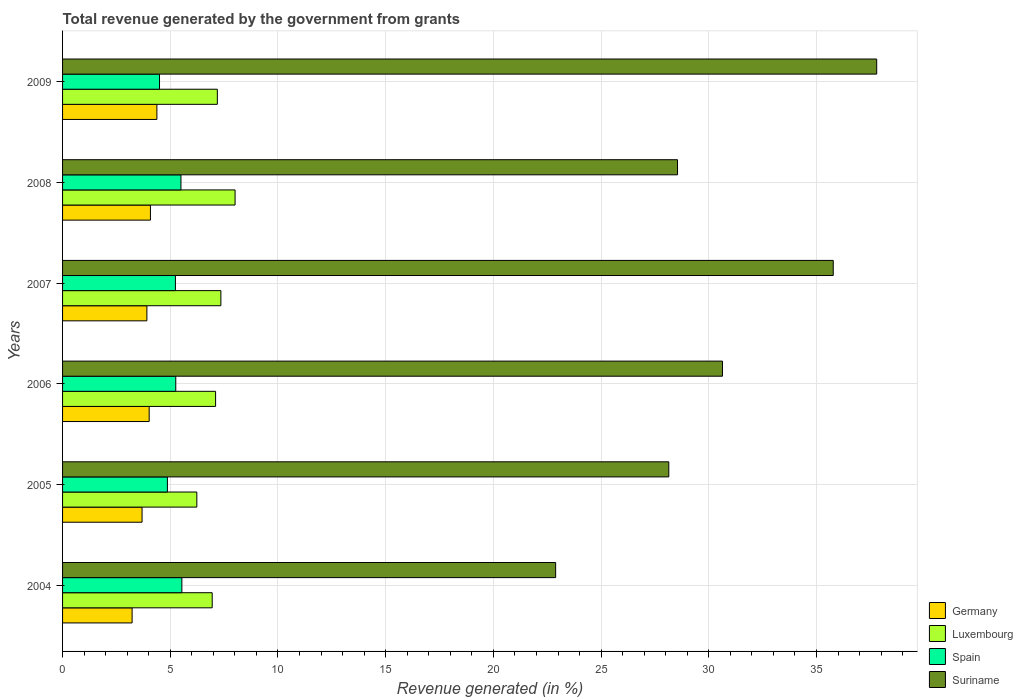How many different coloured bars are there?
Your answer should be very brief. 4. How many groups of bars are there?
Your response must be concise. 6. Are the number of bars per tick equal to the number of legend labels?
Your answer should be compact. Yes. How many bars are there on the 4th tick from the bottom?
Your answer should be very brief. 4. What is the label of the 3rd group of bars from the top?
Your response must be concise. 2007. What is the total revenue generated in Luxembourg in 2006?
Ensure brevity in your answer.  7.1. Across all years, what is the maximum total revenue generated in Suriname?
Offer a terse response. 37.8. Across all years, what is the minimum total revenue generated in Spain?
Your answer should be very brief. 4.5. What is the total total revenue generated in Spain in the graph?
Ensure brevity in your answer.  30.9. What is the difference between the total revenue generated in Suriname in 2005 and that in 2008?
Your answer should be compact. -0.4. What is the difference between the total revenue generated in Spain in 2005 and the total revenue generated in Luxembourg in 2009?
Provide a succinct answer. -2.32. What is the average total revenue generated in Germany per year?
Make the answer very short. 3.89. In the year 2009, what is the difference between the total revenue generated in Germany and total revenue generated in Luxembourg?
Keep it short and to the point. -2.81. In how many years, is the total revenue generated in Spain greater than 12 %?
Your answer should be compact. 0. What is the ratio of the total revenue generated in Suriname in 2005 to that in 2008?
Keep it short and to the point. 0.99. Is the difference between the total revenue generated in Germany in 2008 and 2009 greater than the difference between the total revenue generated in Luxembourg in 2008 and 2009?
Your response must be concise. No. What is the difference between the highest and the second highest total revenue generated in Germany?
Offer a terse response. 0.3. What is the difference between the highest and the lowest total revenue generated in Suriname?
Keep it short and to the point. 14.9. What does the 1st bar from the bottom in 2004 represents?
Provide a short and direct response. Germany. How many bars are there?
Provide a succinct answer. 24. Are all the bars in the graph horizontal?
Make the answer very short. Yes. Does the graph contain any zero values?
Offer a terse response. No. Where does the legend appear in the graph?
Make the answer very short. Bottom right. How many legend labels are there?
Your answer should be compact. 4. How are the legend labels stacked?
Offer a terse response. Vertical. What is the title of the graph?
Make the answer very short. Total revenue generated by the government from grants. Does "Sri Lanka" appear as one of the legend labels in the graph?
Your answer should be very brief. No. What is the label or title of the X-axis?
Give a very brief answer. Revenue generated (in %). What is the Revenue generated (in %) of Germany in 2004?
Offer a very short reply. 3.23. What is the Revenue generated (in %) of Luxembourg in 2004?
Your response must be concise. 6.95. What is the Revenue generated (in %) of Spain in 2004?
Your answer should be compact. 5.54. What is the Revenue generated (in %) in Suriname in 2004?
Your answer should be very brief. 22.89. What is the Revenue generated (in %) of Germany in 2005?
Offer a very short reply. 3.69. What is the Revenue generated (in %) of Luxembourg in 2005?
Give a very brief answer. 6.23. What is the Revenue generated (in %) of Spain in 2005?
Ensure brevity in your answer.  4.87. What is the Revenue generated (in %) in Suriname in 2005?
Ensure brevity in your answer.  28.14. What is the Revenue generated (in %) of Germany in 2006?
Provide a succinct answer. 4.02. What is the Revenue generated (in %) of Luxembourg in 2006?
Your answer should be compact. 7.1. What is the Revenue generated (in %) of Spain in 2006?
Your answer should be compact. 5.26. What is the Revenue generated (in %) of Suriname in 2006?
Your response must be concise. 30.63. What is the Revenue generated (in %) of Germany in 2007?
Make the answer very short. 3.91. What is the Revenue generated (in %) of Luxembourg in 2007?
Offer a very short reply. 7.35. What is the Revenue generated (in %) of Spain in 2007?
Ensure brevity in your answer.  5.24. What is the Revenue generated (in %) in Suriname in 2007?
Provide a succinct answer. 35.78. What is the Revenue generated (in %) in Germany in 2008?
Give a very brief answer. 4.08. What is the Revenue generated (in %) of Luxembourg in 2008?
Make the answer very short. 8.01. What is the Revenue generated (in %) of Spain in 2008?
Ensure brevity in your answer.  5.5. What is the Revenue generated (in %) of Suriname in 2008?
Offer a terse response. 28.55. What is the Revenue generated (in %) in Germany in 2009?
Offer a terse response. 4.38. What is the Revenue generated (in %) in Luxembourg in 2009?
Your response must be concise. 7.19. What is the Revenue generated (in %) of Spain in 2009?
Ensure brevity in your answer.  4.5. What is the Revenue generated (in %) of Suriname in 2009?
Ensure brevity in your answer.  37.8. Across all years, what is the maximum Revenue generated (in %) in Germany?
Offer a very short reply. 4.38. Across all years, what is the maximum Revenue generated (in %) of Luxembourg?
Offer a terse response. 8.01. Across all years, what is the maximum Revenue generated (in %) of Spain?
Your response must be concise. 5.54. Across all years, what is the maximum Revenue generated (in %) in Suriname?
Offer a very short reply. 37.8. Across all years, what is the minimum Revenue generated (in %) of Germany?
Give a very brief answer. 3.23. Across all years, what is the minimum Revenue generated (in %) in Luxembourg?
Keep it short and to the point. 6.23. Across all years, what is the minimum Revenue generated (in %) in Spain?
Ensure brevity in your answer.  4.5. Across all years, what is the minimum Revenue generated (in %) in Suriname?
Keep it short and to the point. 22.89. What is the total Revenue generated (in %) in Germany in the graph?
Provide a short and direct response. 23.31. What is the total Revenue generated (in %) in Luxembourg in the graph?
Keep it short and to the point. 42.83. What is the total Revenue generated (in %) of Spain in the graph?
Your response must be concise. 30.9. What is the total Revenue generated (in %) of Suriname in the graph?
Ensure brevity in your answer.  183.79. What is the difference between the Revenue generated (in %) of Germany in 2004 and that in 2005?
Keep it short and to the point. -0.46. What is the difference between the Revenue generated (in %) in Luxembourg in 2004 and that in 2005?
Offer a very short reply. 0.71. What is the difference between the Revenue generated (in %) of Spain in 2004 and that in 2005?
Your answer should be compact. 0.67. What is the difference between the Revenue generated (in %) in Suriname in 2004 and that in 2005?
Your answer should be very brief. -5.25. What is the difference between the Revenue generated (in %) in Germany in 2004 and that in 2006?
Provide a short and direct response. -0.79. What is the difference between the Revenue generated (in %) in Luxembourg in 2004 and that in 2006?
Ensure brevity in your answer.  -0.16. What is the difference between the Revenue generated (in %) of Spain in 2004 and that in 2006?
Your answer should be very brief. 0.28. What is the difference between the Revenue generated (in %) in Suriname in 2004 and that in 2006?
Give a very brief answer. -7.74. What is the difference between the Revenue generated (in %) in Germany in 2004 and that in 2007?
Your response must be concise. -0.69. What is the difference between the Revenue generated (in %) of Luxembourg in 2004 and that in 2007?
Make the answer very short. -0.4. What is the difference between the Revenue generated (in %) in Spain in 2004 and that in 2007?
Offer a terse response. 0.3. What is the difference between the Revenue generated (in %) of Suriname in 2004 and that in 2007?
Ensure brevity in your answer.  -12.89. What is the difference between the Revenue generated (in %) of Germany in 2004 and that in 2008?
Provide a succinct answer. -0.85. What is the difference between the Revenue generated (in %) of Luxembourg in 2004 and that in 2008?
Ensure brevity in your answer.  -1.06. What is the difference between the Revenue generated (in %) in Spain in 2004 and that in 2008?
Give a very brief answer. 0.04. What is the difference between the Revenue generated (in %) of Suriname in 2004 and that in 2008?
Provide a succinct answer. -5.66. What is the difference between the Revenue generated (in %) of Germany in 2004 and that in 2009?
Offer a terse response. -1.15. What is the difference between the Revenue generated (in %) in Luxembourg in 2004 and that in 2009?
Your answer should be compact. -0.24. What is the difference between the Revenue generated (in %) of Spain in 2004 and that in 2009?
Offer a terse response. 1.04. What is the difference between the Revenue generated (in %) in Suriname in 2004 and that in 2009?
Your response must be concise. -14.9. What is the difference between the Revenue generated (in %) of Germany in 2005 and that in 2006?
Ensure brevity in your answer.  -0.33. What is the difference between the Revenue generated (in %) in Luxembourg in 2005 and that in 2006?
Keep it short and to the point. -0.87. What is the difference between the Revenue generated (in %) in Spain in 2005 and that in 2006?
Provide a short and direct response. -0.39. What is the difference between the Revenue generated (in %) of Suriname in 2005 and that in 2006?
Your answer should be compact. -2.49. What is the difference between the Revenue generated (in %) of Germany in 2005 and that in 2007?
Provide a short and direct response. -0.22. What is the difference between the Revenue generated (in %) of Luxembourg in 2005 and that in 2007?
Your answer should be very brief. -1.12. What is the difference between the Revenue generated (in %) in Spain in 2005 and that in 2007?
Make the answer very short. -0.37. What is the difference between the Revenue generated (in %) in Suriname in 2005 and that in 2007?
Your answer should be compact. -7.63. What is the difference between the Revenue generated (in %) of Germany in 2005 and that in 2008?
Your answer should be very brief. -0.39. What is the difference between the Revenue generated (in %) of Luxembourg in 2005 and that in 2008?
Give a very brief answer. -1.78. What is the difference between the Revenue generated (in %) of Spain in 2005 and that in 2008?
Provide a succinct answer. -0.63. What is the difference between the Revenue generated (in %) in Suriname in 2005 and that in 2008?
Give a very brief answer. -0.4. What is the difference between the Revenue generated (in %) in Germany in 2005 and that in 2009?
Provide a succinct answer. -0.69. What is the difference between the Revenue generated (in %) in Luxembourg in 2005 and that in 2009?
Your response must be concise. -0.95. What is the difference between the Revenue generated (in %) in Spain in 2005 and that in 2009?
Your answer should be compact. 0.37. What is the difference between the Revenue generated (in %) in Suriname in 2005 and that in 2009?
Offer a very short reply. -9.65. What is the difference between the Revenue generated (in %) of Germany in 2006 and that in 2007?
Keep it short and to the point. 0.11. What is the difference between the Revenue generated (in %) in Luxembourg in 2006 and that in 2007?
Ensure brevity in your answer.  -0.25. What is the difference between the Revenue generated (in %) of Spain in 2006 and that in 2007?
Provide a short and direct response. 0.02. What is the difference between the Revenue generated (in %) in Suriname in 2006 and that in 2007?
Give a very brief answer. -5.14. What is the difference between the Revenue generated (in %) of Germany in 2006 and that in 2008?
Offer a terse response. -0.06. What is the difference between the Revenue generated (in %) in Luxembourg in 2006 and that in 2008?
Provide a short and direct response. -0.9. What is the difference between the Revenue generated (in %) of Spain in 2006 and that in 2008?
Give a very brief answer. -0.24. What is the difference between the Revenue generated (in %) of Suriname in 2006 and that in 2008?
Offer a terse response. 2.09. What is the difference between the Revenue generated (in %) of Germany in 2006 and that in 2009?
Ensure brevity in your answer.  -0.36. What is the difference between the Revenue generated (in %) in Luxembourg in 2006 and that in 2009?
Make the answer very short. -0.08. What is the difference between the Revenue generated (in %) in Spain in 2006 and that in 2009?
Give a very brief answer. 0.75. What is the difference between the Revenue generated (in %) of Suriname in 2006 and that in 2009?
Your response must be concise. -7.16. What is the difference between the Revenue generated (in %) in Germany in 2007 and that in 2008?
Your answer should be compact. -0.16. What is the difference between the Revenue generated (in %) in Luxembourg in 2007 and that in 2008?
Offer a very short reply. -0.66. What is the difference between the Revenue generated (in %) of Spain in 2007 and that in 2008?
Your response must be concise. -0.26. What is the difference between the Revenue generated (in %) of Suriname in 2007 and that in 2008?
Ensure brevity in your answer.  7.23. What is the difference between the Revenue generated (in %) in Germany in 2007 and that in 2009?
Ensure brevity in your answer.  -0.46. What is the difference between the Revenue generated (in %) of Luxembourg in 2007 and that in 2009?
Offer a very short reply. 0.16. What is the difference between the Revenue generated (in %) of Spain in 2007 and that in 2009?
Offer a very short reply. 0.74. What is the difference between the Revenue generated (in %) in Suriname in 2007 and that in 2009?
Ensure brevity in your answer.  -2.02. What is the difference between the Revenue generated (in %) of Germany in 2008 and that in 2009?
Your answer should be very brief. -0.3. What is the difference between the Revenue generated (in %) of Luxembourg in 2008 and that in 2009?
Your response must be concise. 0.82. What is the difference between the Revenue generated (in %) of Suriname in 2008 and that in 2009?
Provide a short and direct response. -9.25. What is the difference between the Revenue generated (in %) in Germany in 2004 and the Revenue generated (in %) in Luxembourg in 2005?
Offer a very short reply. -3. What is the difference between the Revenue generated (in %) of Germany in 2004 and the Revenue generated (in %) of Spain in 2005?
Provide a short and direct response. -1.64. What is the difference between the Revenue generated (in %) of Germany in 2004 and the Revenue generated (in %) of Suriname in 2005?
Your answer should be very brief. -24.91. What is the difference between the Revenue generated (in %) in Luxembourg in 2004 and the Revenue generated (in %) in Spain in 2005?
Your answer should be very brief. 2.08. What is the difference between the Revenue generated (in %) in Luxembourg in 2004 and the Revenue generated (in %) in Suriname in 2005?
Provide a succinct answer. -21.2. What is the difference between the Revenue generated (in %) in Spain in 2004 and the Revenue generated (in %) in Suriname in 2005?
Make the answer very short. -22.61. What is the difference between the Revenue generated (in %) of Germany in 2004 and the Revenue generated (in %) of Luxembourg in 2006?
Provide a succinct answer. -3.88. What is the difference between the Revenue generated (in %) of Germany in 2004 and the Revenue generated (in %) of Spain in 2006?
Keep it short and to the point. -2.03. What is the difference between the Revenue generated (in %) in Germany in 2004 and the Revenue generated (in %) in Suriname in 2006?
Your answer should be compact. -27.41. What is the difference between the Revenue generated (in %) of Luxembourg in 2004 and the Revenue generated (in %) of Spain in 2006?
Your answer should be very brief. 1.69. What is the difference between the Revenue generated (in %) in Luxembourg in 2004 and the Revenue generated (in %) in Suriname in 2006?
Keep it short and to the point. -23.69. What is the difference between the Revenue generated (in %) in Spain in 2004 and the Revenue generated (in %) in Suriname in 2006?
Offer a very short reply. -25.1. What is the difference between the Revenue generated (in %) in Germany in 2004 and the Revenue generated (in %) in Luxembourg in 2007?
Offer a terse response. -4.12. What is the difference between the Revenue generated (in %) of Germany in 2004 and the Revenue generated (in %) of Spain in 2007?
Provide a succinct answer. -2.01. What is the difference between the Revenue generated (in %) in Germany in 2004 and the Revenue generated (in %) in Suriname in 2007?
Offer a very short reply. -32.55. What is the difference between the Revenue generated (in %) of Luxembourg in 2004 and the Revenue generated (in %) of Spain in 2007?
Your answer should be compact. 1.71. What is the difference between the Revenue generated (in %) in Luxembourg in 2004 and the Revenue generated (in %) in Suriname in 2007?
Provide a short and direct response. -28.83. What is the difference between the Revenue generated (in %) in Spain in 2004 and the Revenue generated (in %) in Suriname in 2007?
Provide a short and direct response. -30.24. What is the difference between the Revenue generated (in %) in Germany in 2004 and the Revenue generated (in %) in Luxembourg in 2008?
Your answer should be very brief. -4.78. What is the difference between the Revenue generated (in %) in Germany in 2004 and the Revenue generated (in %) in Spain in 2008?
Your answer should be compact. -2.27. What is the difference between the Revenue generated (in %) in Germany in 2004 and the Revenue generated (in %) in Suriname in 2008?
Your answer should be compact. -25.32. What is the difference between the Revenue generated (in %) of Luxembourg in 2004 and the Revenue generated (in %) of Spain in 2008?
Make the answer very short. 1.45. What is the difference between the Revenue generated (in %) in Luxembourg in 2004 and the Revenue generated (in %) in Suriname in 2008?
Ensure brevity in your answer.  -21.6. What is the difference between the Revenue generated (in %) of Spain in 2004 and the Revenue generated (in %) of Suriname in 2008?
Offer a very short reply. -23.01. What is the difference between the Revenue generated (in %) of Germany in 2004 and the Revenue generated (in %) of Luxembourg in 2009?
Your response must be concise. -3.96. What is the difference between the Revenue generated (in %) in Germany in 2004 and the Revenue generated (in %) in Spain in 2009?
Ensure brevity in your answer.  -1.27. What is the difference between the Revenue generated (in %) of Germany in 2004 and the Revenue generated (in %) of Suriname in 2009?
Your answer should be very brief. -34.57. What is the difference between the Revenue generated (in %) in Luxembourg in 2004 and the Revenue generated (in %) in Spain in 2009?
Give a very brief answer. 2.45. What is the difference between the Revenue generated (in %) in Luxembourg in 2004 and the Revenue generated (in %) in Suriname in 2009?
Give a very brief answer. -30.85. What is the difference between the Revenue generated (in %) in Spain in 2004 and the Revenue generated (in %) in Suriname in 2009?
Ensure brevity in your answer.  -32.26. What is the difference between the Revenue generated (in %) of Germany in 2005 and the Revenue generated (in %) of Luxembourg in 2006?
Your response must be concise. -3.41. What is the difference between the Revenue generated (in %) of Germany in 2005 and the Revenue generated (in %) of Spain in 2006?
Offer a very short reply. -1.56. What is the difference between the Revenue generated (in %) in Germany in 2005 and the Revenue generated (in %) in Suriname in 2006?
Make the answer very short. -26.94. What is the difference between the Revenue generated (in %) of Luxembourg in 2005 and the Revenue generated (in %) of Spain in 2006?
Keep it short and to the point. 0.98. What is the difference between the Revenue generated (in %) of Luxembourg in 2005 and the Revenue generated (in %) of Suriname in 2006?
Ensure brevity in your answer.  -24.4. What is the difference between the Revenue generated (in %) in Spain in 2005 and the Revenue generated (in %) in Suriname in 2006?
Your answer should be compact. -25.77. What is the difference between the Revenue generated (in %) in Germany in 2005 and the Revenue generated (in %) in Luxembourg in 2007?
Provide a succinct answer. -3.66. What is the difference between the Revenue generated (in %) in Germany in 2005 and the Revenue generated (in %) in Spain in 2007?
Keep it short and to the point. -1.55. What is the difference between the Revenue generated (in %) in Germany in 2005 and the Revenue generated (in %) in Suriname in 2007?
Make the answer very short. -32.09. What is the difference between the Revenue generated (in %) of Luxembourg in 2005 and the Revenue generated (in %) of Suriname in 2007?
Ensure brevity in your answer.  -29.54. What is the difference between the Revenue generated (in %) in Spain in 2005 and the Revenue generated (in %) in Suriname in 2007?
Ensure brevity in your answer.  -30.91. What is the difference between the Revenue generated (in %) of Germany in 2005 and the Revenue generated (in %) of Luxembourg in 2008?
Offer a very short reply. -4.32. What is the difference between the Revenue generated (in %) in Germany in 2005 and the Revenue generated (in %) in Spain in 2008?
Your answer should be very brief. -1.81. What is the difference between the Revenue generated (in %) in Germany in 2005 and the Revenue generated (in %) in Suriname in 2008?
Make the answer very short. -24.86. What is the difference between the Revenue generated (in %) of Luxembourg in 2005 and the Revenue generated (in %) of Spain in 2008?
Offer a very short reply. 0.74. What is the difference between the Revenue generated (in %) of Luxembourg in 2005 and the Revenue generated (in %) of Suriname in 2008?
Your response must be concise. -22.32. What is the difference between the Revenue generated (in %) in Spain in 2005 and the Revenue generated (in %) in Suriname in 2008?
Ensure brevity in your answer.  -23.68. What is the difference between the Revenue generated (in %) in Germany in 2005 and the Revenue generated (in %) in Luxembourg in 2009?
Your answer should be very brief. -3.49. What is the difference between the Revenue generated (in %) of Germany in 2005 and the Revenue generated (in %) of Spain in 2009?
Provide a succinct answer. -0.81. What is the difference between the Revenue generated (in %) in Germany in 2005 and the Revenue generated (in %) in Suriname in 2009?
Your answer should be compact. -34.1. What is the difference between the Revenue generated (in %) in Luxembourg in 2005 and the Revenue generated (in %) in Spain in 2009?
Your answer should be very brief. 1.73. What is the difference between the Revenue generated (in %) in Luxembourg in 2005 and the Revenue generated (in %) in Suriname in 2009?
Your answer should be very brief. -31.56. What is the difference between the Revenue generated (in %) in Spain in 2005 and the Revenue generated (in %) in Suriname in 2009?
Provide a succinct answer. -32.93. What is the difference between the Revenue generated (in %) of Germany in 2006 and the Revenue generated (in %) of Luxembourg in 2007?
Provide a succinct answer. -3.33. What is the difference between the Revenue generated (in %) in Germany in 2006 and the Revenue generated (in %) in Spain in 2007?
Offer a terse response. -1.22. What is the difference between the Revenue generated (in %) in Germany in 2006 and the Revenue generated (in %) in Suriname in 2007?
Provide a short and direct response. -31.76. What is the difference between the Revenue generated (in %) in Luxembourg in 2006 and the Revenue generated (in %) in Spain in 2007?
Your answer should be compact. 1.86. What is the difference between the Revenue generated (in %) in Luxembourg in 2006 and the Revenue generated (in %) in Suriname in 2007?
Make the answer very short. -28.67. What is the difference between the Revenue generated (in %) in Spain in 2006 and the Revenue generated (in %) in Suriname in 2007?
Provide a short and direct response. -30.52. What is the difference between the Revenue generated (in %) of Germany in 2006 and the Revenue generated (in %) of Luxembourg in 2008?
Provide a short and direct response. -3.99. What is the difference between the Revenue generated (in %) in Germany in 2006 and the Revenue generated (in %) in Spain in 2008?
Make the answer very short. -1.48. What is the difference between the Revenue generated (in %) in Germany in 2006 and the Revenue generated (in %) in Suriname in 2008?
Provide a short and direct response. -24.53. What is the difference between the Revenue generated (in %) of Luxembourg in 2006 and the Revenue generated (in %) of Spain in 2008?
Your answer should be very brief. 1.61. What is the difference between the Revenue generated (in %) of Luxembourg in 2006 and the Revenue generated (in %) of Suriname in 2008?
Offer a terse response. -21.44. What is the difference between the Revenue generated (in %) in Spain in 2006 and the Revenue generated (in %) in Suriname in 2008?
Ensure brevity in your answer.  -23.29. What is the difference between the Revenue generated (in %) in Germany in 2006 and the Revenue generated (in %) in Luxembourg in 2009?
Make the answer very short. -3.16. What is the difference between the Revenue generated (in %) of Germany in 2006 and the Revenue generated (in %) of Spain in 2009?
Your answer should be compact. -0.48. What is the difference between the Revenue generated (in %) in Germany in 2006 and the Revenue generated (in %) in Suriname in 2009?
Your answer should be compact. -33.77. What is the difference between the Revenue generated (in %) in Luxembourg in 2006 and the Revenue generated (in %) in Spain in 2009?
Offer a terse response. 2.6. What is the difference between the Revenue generated (in %) in Luxembourg in 2006 and the Revenue generated (in %) in Suriname in 2009?
Keep it short and to the point. -30.69. What is the difference between the Revenue generated (in %) of Spain in 2006 and the Revenue generated (in %) of Suriname in 2009?
Provide a succinct answer. -32.54. What is the difference between the Revenue generated (in %) in Germany in 2007 and the Revenue generated (in %) in Luxembourg in 2008?
Make the answer very short. -4.09. What is the difference between the Revenue generated (in %) in Germany in 2007 and the Revenue generated (in %) in Spain in 2008?
Offer a very short reply. -1.58. What is the difference between the Revenue generated (in %) of Germany in 2007 and the Revenue generated (in %) of Suriname in 2008?
Your response must be concise. -24.63. What is the difference between the Revenue generated (in %) of Luxembourg in 2007 and the Revenue generated (in %) of Spain in 2008?
Provide a succinct answer. 1.85. What is the difference between the Revenue generated (in %) of Luxembourg in 2007 and the Revenue generated (in %) of Suriname in 2008?
Ensure brevity in your answer.  -21.2. What is the difference between the Revenue generated (in %) of Spain in 2007 and the Revenue generated (in %) of Suriname in 2008?
Provide a short and direct response. -23.31. What is the difference between the Revenue generated (in %) of Germany in 2007 and the Revenue generated (in %) of Luxembourg in 2009?
Offer a very short reply. -3.27. What is the difference between the Revenue generated (in %) of Germany in 2007 and the Revenue generated (in %) of Spain in 2009?
Give a very brief answer. -0.59. What is the difference between the Revenue generated (in %) in Germany in 2007 and the Revenue generated (in %) in Suriname in 2009?
Provide a short and direct response. -33.88. What is the difference between the Revenue generated (in %) in Luxembourg in 2007 and the Revenue generated (in %) in Spain in 2009?
Give a very brief answer. 2.85. What is the difference between the Revenue generated (in %) in Luxembourg in 2007 and the Revenue generated (in %) in Suriname in 2009?
Your answer should be very brief. -30.45. What is the difference between the Revenue generated (in %) of Spain in 2007 and the Revenue generated (in %) of Suriname in 2009?
Your answer should be compact. -32.56. What is the difference between the Revenue generated (in %) in Germany in 2008 and the Revenue generated (in %) in Luxembourg in 2009?
Your answer should be compact. -3.11. What is the difference between the Revenue generated (in %) of Germany in 2008 and the Revenue generated (in %) of Spain in 2009?
Keep it short and to the point. -0.42. What is the difference between the Revenue generated (in %) in Germany in 2008 and the Revenue generated (in %) in Suriname in 2009?
Offer a very short reply. -33.72. What is the difference between the Revenue generated (in %) of Luxembourg in 2008 and the Revenue generated (in %) of Spain in 2009?
Offer a very short reply. 3.51. What is the difference between the Revenue generated (in %) in Luxembourg in 2008 and the Revenue generated (in %) in Suriname in 2009?
Keep it short and to the point. -29.79. What is the difference between the Revenue generated (in %) of Spain in 2008 and the Revenue generated (in %) of Suriname in 2009?
Your response must be concise. -32.3. What is the average Revenue generated (in %) in Germany per year?
Your answer should be compact. 3.89. What is the average Revenue generated (in %) in Luxembourg per year?
Give a very brief answer. 7.14. What is the average Revenue generated (in %) of Spain per year?
Keep it short and to the point. 5.15. What is the average Revenue generated (in %) in Suriname per year?
Provide a succinct answer. 30.63. In the year 2004, what is the difference between the Revenue generated (in %) in Germany and Revenue generated (in %) in Luxembourg?
Ensure brevity in your answer.  -3.72. In the year 2004, what is the difference between the Revenue generated (in %) of Germany and Revenue generated (in %) of Spain?
Offer a very short reply. -2.31. In the year 2004, what is the difference between the Revenue generated (in %) in Germany and Revenue generated (in %) in Suriname?
Your answer should be compact. -19.66. In the year 2004, what is the difference between the Revenue generated (in %) in Luxembourg and Revenue generated (in %) in Spain?
Keep it short and to the point. 1.41. In the year 2004, what is the difference between the Revenue generated (in %) of Luxembourg and Revenue generated (in %) of Suriname?
Keep it short and to the point. -15.94. In the year 2004, what is the difference between the Revenue generated (in %) of Spain and Revenue generated (in %) of Suriname?
Your response must be concise. -17.35. In the year 2005, what is the difference between the Revenue generated (in %) of Germany and Revenue generated (in %) of Luxembourg?
Provide a succinct answer. -2.54. In the year 2005, what is the difference between the Revenue generated (in %) in Germany and Revenue generated (in %) in Spain?
Offer a very short reply. -1.18. In the year 2005, what is the difference between the Revenue generated (in %) of Germany and Revenue generated (in %) of Suriname?
Provide a succinct answer. -24.45. In the year 2005, what is the difference between the Revenue generated (in %) of Luxembourg and Revenue generated (in %) of Spain?
Offer a very short reply. 1.37. In the year 2005, what is the difference between the Revenue generated (in %) in Luxembourg and Revenue generated (in %) in Suriname?
Provide a short and direct response. -21.91. In the year 2005, what is the difference between the Revenue generated (in %) of Spain and Revenue generated (in %) of Suriname?
Provide a short and direct response. -23.28. In the year 2006, what is the difference between the Revenue generated (in %) of Germany and Revenue generated (in %) of Luxembourg?
Ensure brevity in your answer.  -3.08. In the year 2006, what is the difference between the Revenue generated (in %) of Germany and Revenue generated (in %) of Spain?
Your answer should be very brief. -1.24. In the year 2006, what is the difference between the Revenue generated (in %) of Germany and Revenue generated (in %) of Suriname?
Your answer should be compact. -26.61. In the year 2006, what is the difference between the Revenue generated (in %) in Luxembourg and Revenue generated (in %) in Spain?
Your response must be concise. 1.85. In the year 2006, what is the difference between the Revenue generated (in %) of Luxembourg and Revenue generated (in %) of Suriname?
Give a very brief answer. -23.53. In the year 2006, what is the difference between the Revenue generated (in %) in Spain and Revenue generated (in %) in Suriname?
Your answer should be very brief. -25.38. In the year 2007, what is the difference between the Revenue generated (in %) of Germany and Revenue generated (in %) of Luxembourg?
Your answer should be compact. -3.43. In the year 2007, what is the difference between the Revenue generated (in %) of Germany and Revenue generated (in %) of Spain?
Keep it short and to the point. -1.32. In the year 2007, what is the difference between the Revenue generated (in %) of Germany and Revenue generated (in %) of Suriname?
Offer a very short reply. -31.86. In the year 2007, what is the difference between the Revenue generated (in %) of Luxembourg and Revenue generated (in %) of Spain?
Offer a very short reply. 2.11. In the year 2007, what is the difference between the Revenue generated (in %) in Luxembourg and Revenue generated (in %) in Suriname?
Offer a very short reply. -28.43. In the year 2007, what is the difference between the Revenue generated (in %) of Spain and Revenue generated (in %) of Suriname?
Your response must be concise. -30.54. In the year 2008, what is the difference between the Revenue generated (in %) in Germany and Revenue generated (in %) in Luxembourg?
Give a very brief answer. -3.93. In the year 2008, what is the difference between the Revenue generated (in %) in Germany and Revenue generated (in %) in Spain?
Provide a succinct answer. -1.42. In the year 2008, what is the difference between the Revenue generated (in %) in Germany and Revenue generated (in %) in Suriname?
Offer a terse response. -24.47. In the year 2008, what is the difference between the Revenue generated (in %) of Luxembourg and Revenue generated (in %) of Spain?
Your response must be concise. 2.51. In the year 2008, what is the difference between the Revenue generated (in %) of Luxembourg and Revenue generated (in %) of Suriname?
Offer a terse response. -20.54. In the year 2008, what is the difference between the Revenue generated (in %) in Spain and Revenue generated (in %) in Suriname?
Offer a terse response. -23.05. In the year 2009, what is the difference between the Revenue generated (in %) of Germany and Revenue generated (in %) of Luxembourg?
Offer a very short reply. -2.81. In the year 2009, what is the difference between the Revenue generated (in %) in Germany and Revenue generated (in %) in Spain?
Offer a very short reply. -0.12. In the year 2009, what is the difference between the Revenue generated (in %) of Germany and Revenue generated (in %) of Suriname?
Your answer should be compact. -33.42. In the year 2009, what is the difference between the Revenue generated (in %) in Luxembourg and Revenue generated (in %) in Spain?
Offer a terse response. 2.68. In the year 2009, what is the difference between the Revenue generated (in %) in Luxembourg and Revenue generated (in %) in Suriname?
Give a very brief answer. -30.61. In the year 2009, what is the difference between the Revenue generated (in %) of Spain and Revenue generated (in %) of Suriname?
Your response must be concise. -33.29. What is the ratio of the Revenue generated (in %) in Germany in 2004 to that in 2005?
Offer a very short reply. 0.87. What is the ratio of the Revenue generated (in %) of Luxembourg in 2004 to that in 2005?
Offer a very short reply. 1.11. What is the ratio of the Revenue generated (in %) of Spain in 2004 to that in 2005?
Provide a succinct answer. 1.14. What is the ratio of the Revenue generated (in %) in Suriname in 2004 to that in 2005?
Your answer should be compact. 0.81. What is the ratio of the Revenue generated (in %) of Germany in 2004 to that in 2006?
Give a very brief answer. 0.8. What is the ratio of the Revenue generated (in %) in Luxembourg in 2004 to that in 2006?
Ensure brevity in your answer.  0.98. What is the ratio of the Revenue generated (in %) in Spain in 2004 to that in 2006?
Offer a very short reply. 1.05. What is the ratio of the Revenue generated (in %) in Suriname in 2004 to that in 2006?
Offer a very short reply. 0.75. What is the ratio of the Revenue generated (in %) in Germany in 2004 to that in 2007?
Give a very brief answer. 0.82. What is the ratio of the Revenue generated (in %) in Luxembourg in 2004 to that in 2007?
Offer a very short reply. 0.95. What is the ratio of the Revenue generated (in %) in Spain in 2004 to that in 2007?
Provide a short and direct response. 1.06. What is the ratio of the Revenue generated (in %) in Suriname in 2004 to that in 2007?
Give a very brief answer. 0.64. What is the ratio of the Revenue generated (in %) in Germany in 2004 to that in 2008?
Give a very brief answer. 0.79. What is the ratio of the Revenue generated (in %) in Luxembourg in 2004 to that in 2008?
Your answer should be compact. 0.87. What is the ratio of the Revenue generated (in %) in Spain in 2004 to that in 2008?
Make the answer very short. 1.01. What is the ratio of the Revenue generated (in %) of Suriname in 2004 to that in 2008?
Offer a terse response. 0.8. What is the ratio of the Revenue generated (in %) of Germany in 2004 to that in 2009?
Your response must be concise. 0.74. What is the ratio of the Revenue generated (in %) of Luxembourg in 2004 to that in 2009?
Your answer should be compact. 0.97. What is the ratio of the Revenue generated (in %) of Spain in 2004 to that in 2009?
Ensure brevity in your answer.  1.23. What is the ratio of the Revenue generated (in %) of Suriname in 2004 to that in 2009?
Your response must be concise. 0.61. What is the ratio of the Revenue generated (in %) of Germany in 2005 to that in 2006?
Keep it short and to the point. 0.92. What is the ratio of the Revenue generated (in %) of Luxembourg in 2005 to that in 2006?
Provide a succinct answer. 0.88. What is the ratio of the Revenue generated (in %) in Spain in 2005 to that in 2006?
Offer a very short reply. 0.93. What is the ratio of the Revenue generated (in %) in Suriname in 2005 to that in 2006?
Ensure brevity in your answer.  0.92. What is the ratio of the Revenue generated (in %) in Germany in 2005 to that in 2007?
Your answer should be very brief. 0.94. What is the ratio of the Revenue generated (in %) of Luxembourg in 2005 to that in 2007?
Offer a very short reply. 0.85. What is the ratio of the Revenue generated (in %) of Spain in 2005 to that in 2007?
Make the answer very short. 0.93. What is the ratio of the Revenue generated (in %) in Suriname in 2005 to that in 2007?
Your response must be concise. 0.79. What is the ratio of the Revenue generated (in %) in Germany in 2005 to that in 2008?
Make the answer very short. 0.9. What is the ratio of the Revenue generated (in %) of Luxembourg in 2005 to that in 2008?
Your answer should be very brief. 0.78. What is the ratio of the Revenue generated (in %) in Spain in 2005 to that in 2008?
Keep it short and to the point. 0.89. What is the ratio of the Revenue generated (in %) of Suriname in 2005 to that in 2008?
Offer a terse response. 0.99. What is the ratio of the Revenue generated (in %) of Germany in 2005 to that in 2009?
Keep it short and to the point. 0.84. What is the ratio of the Revenue generated (in %) of Luxembourg in 2005 to that in 2009?
Provide a short and direct response. 0.87. What is the ratio of the Revenue generated (in %) in Spain in 2005 to that in 2009?
Provide a short and direct response. 1.08. What is the ratio of the Revenue generated (in %) of Suriname in 2005 to that in 2009?
Ensure brevity in your answer.  0.74. What is the ratio of the Revenue generated (in %) of Germany in 2006 to that in 2007?
Keep it short and to the point. 1.03. What is the ratio of the Revenue generated (in %) in Luxembourg in 2006 to that in 2007?
Your answer should be compact. 0.97. What is the ratio of the Revenue generated (in %) in Suriname in 2006 to that in 2007?
Your answer should be very brief. 0.86. What is the ratio of the Revenue generated (in %) of Germany in 2006 to that in 2008?
Ensure brevity in your answer.  0.99. What is the ratio of the Revenue generated (in %) of Luxembourg in 2006 to that in 2008?
Your answer should be very brief. 0.89. What is the ratio of the Revenue generated (in %) in Spain in 2006 to that in 2008?
Your response must be concise. 0.96. What is the ratio of the Revenue generated (in %) in Suriname in 2006 to that in 2008?
Give a very brief answer. 1.07. What is the ratio of the Revenue generated (in %) of Germany in 2006 to that in 2009?
Give a very brief answer. 0.92. What is the ratio of the Revenue generated (in %) in Luxembourg in 2006 to that in 2009?
Your answer should be very brief. 0.99. What is the ratio of the Revenue generated (in %) in Spain in 2006 to that in 2009?
Your response must be concise. 1.17. What is the ratio of the Revenue generated (in %) of Suriname in 2006 to that in 2009?
Your response must be concise. 0.81. What is the ratio of the Revenue generated (in %) of Germany in 2007 to that in 2008?
Ensure brevity in your answer.  0.96. What is the ratio of the Revenue generated (in %) of Luxembourg in 2007 to that in 2008?
Offer a terse response. 0.92. What is the ratio of the Revenue generated (in %) in Spain in 2007 to that in 2008?
Offer a terse response. 0.95. What is the ratio of the Revenue generated (in %) in Suriname in 2007 to that in 2008?
Your response must be concise. 1.25. What is the ratio of the Revenue generated (in %) in Germany in 2007 to that in 2009?
Provide a succinct answer. 0.89. What is the ratio of the Revenue generated (in %) of Luxembourg in 2007 to that in 2009?
Your answer should be compact. 1.02. What is the ratio of the Revenue generated (in %) of Spain in 2007 to that in 2009?
Your response must be concise. 1.16. What is the ratio of the Revenue generated (in %) of Suriname in 2007 to that in 2009?
Provide a short and direct response. 0.95. What is the ratio of the Revenue generated (in %) of Germany in 2008 to that in 2009?
Ensure brevity in your answer.  0.93. What is the ratio of the Revenue generated (in %) in Luxembourg in 2008 to that in 2009?
Make the answer very short. 1.11. What is the ratio of the Revenue generated (in %) of Spain in 2008 to that in 2009?
Offer a terse response. 1.22. What is the ratio of the Revenue generated (in %) in Suriname in 2008 to that in 2009?
Your answer should be very brief. 0.76. What is the difference between the highest and the second highest Revenue generated (in %) in Germany?
Your response must be concise. 0.3. What is the difference between the highest and the second highest Revenue generated (in %) in Luxembourg?
Offer a very short reply. 0.66. What is the difference between the highest and the second highest Revenue generated (in %) in Spain?
Offer a terse response. 0.04. What is the difference between the highest and the second highest Revenue generated (in %) of Suriname?
Offer a terse response. 2.02. What is the difference between the highest and the lowest Revenue generated (in %) of Germany?
Your answer should be very brief. 1.15. What is the difference between the highest and the lowest Revenue generated (in %) of Luxembourg?
Provide a succinct answer. 1.78. What is the difference between the highest and the lowest Revenue generated (in %) in Spain?
Your response must be concise. 1.04. What is the difference between the highest and the lowest Revenue generated (in %) in Suriname?
Offer a terse response. 14.9. 